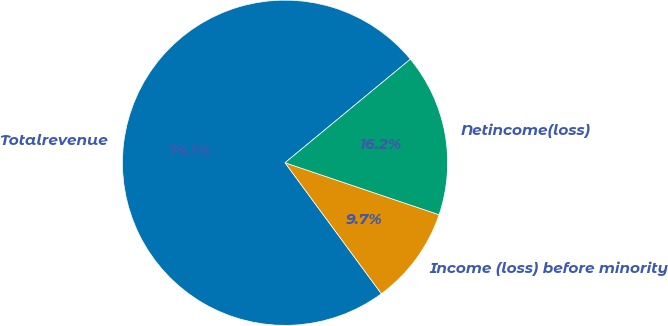Convert chart to OTSL. <chart><loc_0><loc_0><loc_500><loc_500><pie_chart><fcel>Totalrevenue<fcel>Income (loss) before minority<fcel>Netincome(loss)<nl><fcel>74.1%<fcel>9.73%<fcel>16.17%<nl></chart> 